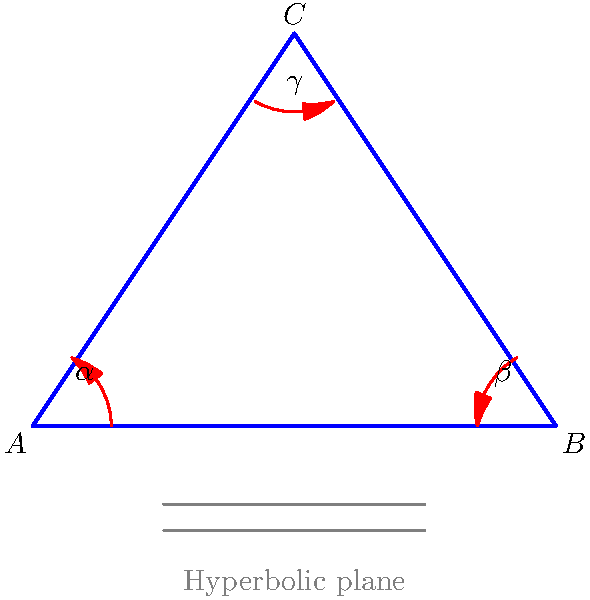In a hyperbolic plane represented by three harp strings forming a triangle ABC, the interior angles are $\alpha$, $\beta$, and $\gamma$. If the sum of these angles is 150°, how many degrees less than the sum of angles in a Euclidean triangle is this hyperbolic triangle? To solve this problem, let's follow these steps:

1) Recall that in Euclidean geometry, the sum of interior angles of a triangle is always 180°.

2) In hyperbolic geometry, the sum of interior angles of a triangle is always less than 180°. This is a key difference between Euclidean and hyperbolic geometries.

3) We are given that in this hyperbolic triangle:

   $\alpha + \beta + \gamma = 150°$

4) To find how many degrees less this is compared to a Euclidean triangle, we need to subtract this sum from 180°:

   $180° - (150°) = 30°$

5) This difference is called the defect of the hyperbolic triangle. In hyperbolic geometry, the defect is directly related to the area of the triangle.

6) Interestingly, in the context of a harp, this could be visualized as the "tension" created by the curvature of the hyperbolic plane, affecting the tightness and pitch of the harp strings representing the triangle's sides.
Answer: 30° 